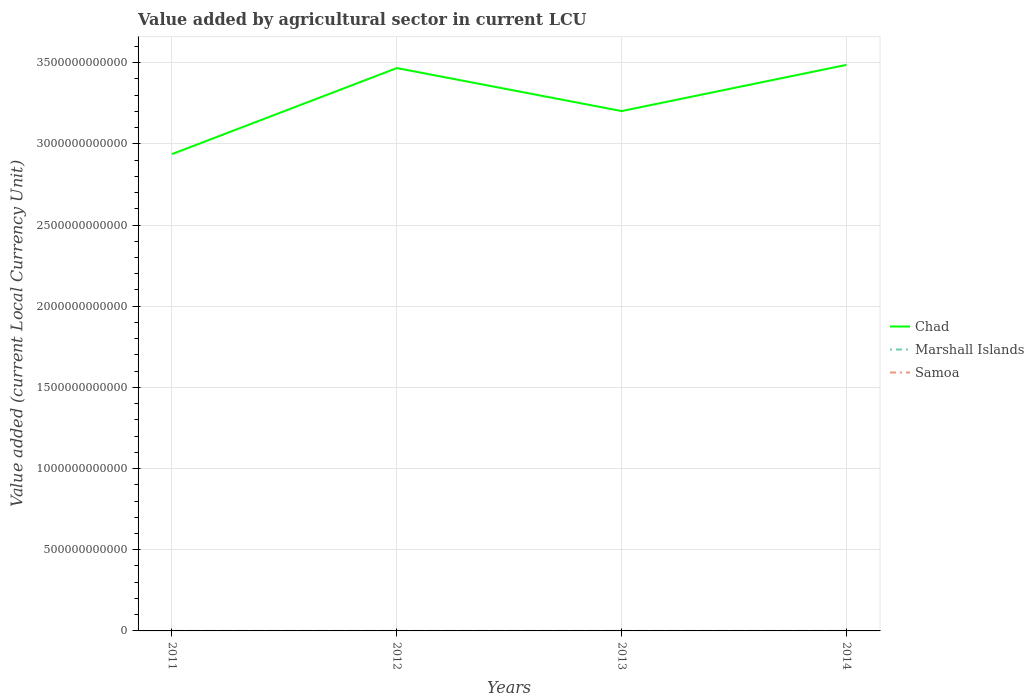Is the number of lines equal to the number of legend labels?
Provide a succinct answer. Yes. Across all years, what is the maximum value added by agricultural sector in Marshall Islands?
Offer a very short reply. 2.65e+07. What is the total value added by agricultural sector in Marshall Islands in the graph?
Offer a very short reply. -1.33e+07. What is the difference between the highest and the second highest value added by agricultural sector in Marshall Islands?
Provide a short and direct response. 1.33e+07. What is the difference between the highest and the lowest value added by agricultural sector in Samoa?
Make the answer very short. 2. Is the value added by agricultural sector in Samoa strictly greater than the value added by agricultural sector in Chad over the years?
Ensure brevity in your answer.  Yes. How many years are there in the graph?
Make the answer very short. 4. What is the difference between two consecutive major ticks on the Y-axis?
Offer a terse response. 5.00e+11. Are the values on the major ticks of Y-axis written in scientific E-notation?
Keep it short and to the point. No. Does the graph contain grids?
Provide a succinct answer. Yes. What is the title of the graph?
Provide a succinct answer. Value added by agricultural sector in current LCU. What is the label or title of the X-axis?
Make the answer very short. Years. What is the label or title of the Y-axis?
Make the answer very short. Value added (current Local Currency Unit). What is the Value added (current Local Currency Unit) of Chad in 2011?
Your response must be concise. 2.94e+12. What is the Value added (current Local Currency Unit) in Marshall Islands in 2011?
Offer a very short reply. 2.65e+07. What is the Value added (current Local Currency Unit) in Samoa in 2011?
Provide a short and direct response. 1.68e+08. What is the Value added (current Local Currency Unit) in Chad in 2012?
Offer a very short reply. 3.47e+12. What is the Value added (current Local Currency Unit) of Marshall Islands in 2012?
Give a very brief answer. 3.96e+07. What is the Value added (current Local Currency Unit) in Samoa in 2012?
Your answer should be very brief. 1.73e+08. What is the Value added (current Local Currency Unit) in Chad in 2013?
Provide a succinct answer. 3.20e+12. What is the Value added (current Local Currency Unit) of Marshall Islands in 2013?
Provide a short and direct response. 3.98e+07. What is the Value added (current Local Currency Unit) in Samoa in 2013?
Ensure brevity in your answer.  1.78e+08. What is the Value added (current Local Currency Unit) in Chad in 2014?
Your answer should be very brief. 3.49e+12. What is the Value added (current Local Currency Unit) in Marshall Islands in 2014?
Offer a very short reply. 3.30e+07. What is the Value added (current Local Currency Unit) in Samoa in 2014?
Give a very brief answer. 1.76e+08. Across all years, what is the maximum Value added (current Local Currency Unit) of Chad?
Make the answer very short. 3.49e+12. Across all years, what is the maximum Value added (current Local Currency Unit) in Marshall Islands?
Offer a very short reply. 3.98e+07. Across all years, what is the maximum Value added (current Local Currency Unit) in Samoa?
Provide a short and direct response. 1.78e+08. Across all years, what is the minimum Value added (current Local Currency Unit) in Chad?
Offer a terse response. 2.94e+12. Across all years, what is the minimum Value added (current Local Currency Unit) of Marshall Islands?
Your response must be concise. 2.65e+07. Across all years, what is the minimum Value added (current Local Currency Unit) in Samoa?
Offer a very short reply. 1.68e+08. What is the total Value added (current Local Currency Unit) in Chad in the graph?
Provide a succinct answer. 1.31e+13. What is the total Value added (current Local Currency Unit) in Marshall Islands in the graph?
Offer a terse response. 1.39e+08. What is the total Value added (current Local Currency Unit) of Samoa in the graph?
Give a very brief answer. 6.95e+08. What is the difference between the Value added (current Local Currency Unit) in Chad in 2011 and that in 2012?
Offer a very short reply. -5.30e+11. What is the difference between the Value added (current Local Currency Unit) in Marshall Islands in 2011 and that in 2012?
Keep it short and to the point. -1.31e+07. What is the difference between the Value added (current Local Currency Unit) of Samoa in 2011 and that in 2012?
Give a very brief answer. -4.91e+06. What is the difference between the Value added (current Local Currency Unit) in Chad in 2011 and that in 2013?
Keep it short and to the point. -2.65e+11. What is the difference between the Value added (current Local Currency Unit) in Marshall Islands in 2011 and that in 2013?
Your answer should be compact. -1.33e+07. What is the difference between the Value added (current Local Currency Unit) of Samoa in 2011 and that in 2013?
Provide a short and direct response. -9.50e+06. What is the difference between the Value added (current Local Currency Unit) in Chad in 2011 and that in 2014?
Offer a very short reply. -5.50e+11. What is the difference between the Value added (current Local Currency Unit) in Marshall Islands in 2011 and that in 2014?
Provide a short and direct response. -6.55e+06. What is the difference between the Value added (current Local Currency Unit) in Samoa in 2011 and that in 2014?
Provide a short and direct response. -7.87e+06. What is the difference between the Value added (current Local Currency Unit) in Chad in 2012 and that in 2013?
Keep it short and to the point. 2.65e+11. What is the difference between the Value added (current Local Currency Unit) of Marshall Islands in 2012 and that in 2013?
Your response must be concise. -2.11e+05. What is the difference between the Value added (current Local Currency Unit) of Samoa in 2012 and that in 2013?
Offer a very short reply. -4.58e+06. What is the difference between the Value added (current Local Currency Unit) of Chad in 2012 and that in 2014?
Keep it short and to the point. -1.97e+1. What is the difference between the Value added (current Local Currency Unit) in Marshall Islands in 2012 and that in 2014?
Provide a succinct answer. 6.57e+06. What is the difference between the Value added (current Local Currency Unit) in Samoa in 2012 and that in 2014?
Ensure brevity in your answer.  -2.95e+06. What is the difference between the Value added (current Local Currency Unit) in Chad in 2013 and that in 2014?
Your answer should be very brief. -2.84e+11. What is the difference between the Value added (current Local Currency Unit) in Marshall Islands in 2013 and that in 2014?
Your answer should be very brief. 6.78e+06. What is the difference between the Value added (current Local Currency Unit) in Samoa in 2013 and that in 2014?
Your answer should be compact. 1.63e+06. What is the difference between the Value added (current Local Currency Unit) of Chad in 2011 and the Value added (current Local Currency Unit) of Marshall Islands in 2012?
Provide a short and direct response. 2.94e+12. What is the difference between the Value added (current Local Currency Unit) of Chad in 2011 and the Value added (current Local Currency Unit) of Samoa in 2012?
Make the answer very short. 2.94e+12. What is the difference between the Value added (current Local Currency Unit) in Marshall Islands in 2011 and the Value added (current Local Currency Unit) in Samoa in 2012?
Provide a short and direct response. -1.47e+08. What is the difference between the Value added (current Local Currency Unit) of Chad in 2011 and the Value added (current Local Currency Unit) of Marshall Islands in 2013?
Ensure brevity in your answer.  2.94e+12. What is the difference between the Value added (current Local Currency Unit) of Chad in 2011 and the Value added (current Local Currency Unit) of Samoa in 2013?
Make the answer very short. 2.94e+12. What is the difference between the Value added (current Local Currency Unit) of Marshall Islands in 2011 and the Value added (current Local Currency Unit) of Samoa in 2013?
Provide a succinct answer. -1.51e+08. What is the difference between the Value added (current Local Currency Unit) of Chad in 2011 and the Value added (current Local Currency Unit) of Marshall Islands in 2014?
Your answer should be compact. 2.94e+12. What is the difference between the Value added (current Local Currency Unit) of Chad in 2011 and the Value added (current Local Currency Unit) of Samoa in 2014?
Ensure brevity in your answer.  2.94e+12. What is the difference between the Value added (current Local Currency Unit) in Marshall Islands in 2011 and the Value added (current Local Currency Unit) in Samoa in 2014?
Provide a succinct answer. -1.50e+08. What is the difference between the Value added (current Local Currency Unit) of Chad in 2012 and the Value added (current Local Currency Unit) of Marshall Islands in 2013?
Make the answer very short. 3.47e+12. What is the difference between the Value added (current Local Currency Unit) in Chad in 2012 and the Value added (current Local Currency Unit) in Samoa in 2013?
Your answer should be very brief. 3.47e+12. What is the difference between the Value added (current Local Currency Unit) in Marshall Islands in 2012 and the Value added (current Local Currency Unit) in Samoa in 2013?
Offer a very short reply. -1.38e+08. What is the difference between the Value added (current Local Currency Unit) of Chad in 2012 and the Value added (current Local Currency Unit) of Marshall Islands in 2014?
Keep it short and to the point. 3.47e+12. What is the difference between the Value added (current Local Currency Unit) in Chad in 2012 and the Value added (current Local Currency Unit) in Samoa in 2014?
Make the answer very short. 3.47e+12. What is the difference between the Value added (current Local Currency Unit) of Marshall Islands in 2012 and the Value added (current Local Currency Unit) of Samoa in 2014?
Your answer should be very brief. -1.36e+08. What is the difference between the Value added (current Local Currency Unit) of Chad in 2013 and the Value added (current Local Currency Unit) of Marshall Islands in 2014?
Keep it short and to the point. 3.20e+12. What is the difference between the Value added (current Local Currency Unit) in Chad in 2013 and the Value added (current Local Currency Unit) in Samoa in 2014?
Your answer should be compact. 3.20e+12. What is the difference between the Value added (current Local Currency Unit) in Marshall Islands in 2013 and the Value added (current Local Currency Unit) in Samoa in 2014?
Ensure brevity in your answer.  -1.36e+08. What is the average Value added (current Local Currency Unit) of Chad per year?
Your answer should be very brief. 3.27e+12. What is the average Value added (current Local Currency Unit) of Marshall Islands per year?
Ensure brevity in your answer.  3.47e+07. What is the average Value added (current Local Currency Unit) of Samoa per year?
Make the answer very short. 1.74e+08. In the year 2011, what is the difference between the Value added (current Local Currency Unit) of Chad and Value added (current Local Currency Unit) of Marshall Islands?
Ensure brevity in your answer.  2.94e+12. In the year 2011, what is the difference between the Value added (current Local Currency Unit) in Chad and Value added (current Local Currency Unit) in Samoa?
Your answer should be compact. 2.94e+12. In the year 2011, what is the difference between the Value added (current Local Currency Unit) of Marshall Islands and Value added (current Local Currency Unit) of Samoa?
Provide a short and direct response. -1.42e+08. In the year 2012, what is the difference between the Value added (current Local Currency Unit) in Chad and Value added (current Local Currency Unit) in Marshall Islands?
Ensure brevity in your answer.  3.47e+12. In the year 2012, what is the difference between the Value added (current Local Currency Unit) in Chad and Value added (current Local Currency Unit) in Samoa?
Your response must be concise. 3.47e+12. In the year 2012, what is the difference between the Value added (current Local Currency Unit) in Marshall Islands and Value added (current Local Currency Unit) in Samoa?
Your answer should be very brief. -1.33e+08. In the year 2013, what is the difference between the Value added (current Local Currency Unit) of Chad and Value added (current Local Currency Unit) of Marshall Islands?
Your answer should be very brief. 3.20e+12. In the year 2013, what is the difference between the Value added (current Local Currency Unit) in Chad and Value added (current Local Currency Unit) in Samoa?
Provide a succinct answer. 3.20e+12. In the year 2013, what is the difference between the Value added (current Local Currency Unit) in Marshall Islands and Value added (current Local Currency Unit) in Samoa?
Ensure brevity in your answer.  -1.38e+08. In the year 2014, what is the difference between the Value added (current Local Currency Unit) of Chad and Value added (current Local Currency Unit) of Marshall Islands?
Ensure brevity in your answer.  3.49e+12. In the year 2014, what is the difference between the Value added (current Local Currency Unit) in Chad and Value added (current Local Currency Unit) in Samoa?
Ensure brevity in your answer.  3.49e+12. In the year 2014, what is the difference between the Value added (current Local Currency Unit) of Marshall Islands and Value added (current Local Currency Unit) of Samoa?
Offer a very short reply. -1.43e+08. What is the ratio of the Value added (current Local Currency Unit) of Chad in 2011 to that in 2012?
Keep it short and to the point. 0.85. What is the ratio of the Value added (current Local Currency Unit) of Marshall Islands in 2011 to that in 2012?
Your answer should be compact. 0.67. What is the ratio of the Value added (current Local Currency Unit) of Samoa in 2011 to that in 2012?
Keep it short and to the point. 0.97. What is the ratio of the Value added (current Local Currency Unit) of Chad in 2011 to that in 2013?
Offer a terse response. 0.92. What is the ratio of the Value added (current Local Currency Unit) of Marshall Islands in 2011 to that in 2013?
Your answer should be very brief. 0.66. What is the ratio of the Value added (current Local Currency Unit) in Samoa in 2011 to that in 2013?
Keep it short and to the point. 0.95. What is the ratio of the Value added (current Local Currency Unit) of Chad in 2011 to that in 2014?
Your answer should be very brief. 0.84. What is the ratio of the Value added (current Local Currency Unit) in Marshall Islands in 2011 to that in 2014?
Provide a succinct answer. 0.8. What is the ratio of the Value added (current Local Currency Unit) in Samoa in 2011 to that in 2014?
Provide a short and direct response. 0.96. What is the ratio of the Value added (current Local Currency Unit) of Chad in 2012 to that in 2013?
Make the answer very short. 1.08. What is the ratio of the Value added (current Local Currency Unit) in Samoa in 2012 to that in 2013?
Your answer should be very brief. 0.97. What is the ratio of the Value added (current Local Currency Unit) of Chad in 2012 to that in 2014?
Ensure brevity in your answer.  0.99. What is the ratio of the Value added (current Local Currency Unit) in Marshall Islands in 2012 to that in 2014?
Your answer should be compact. 1.2. What is the ratio of the Value added (current Local Currency Unit) in Samoa in 2012 to that in 2014?
Offer a very short reply. 0.98. What is the ratio of the Value added (current Local Currency Unit) of Chad in 2013 to that in 2014?
Your answer should be compact. 0.92. What is the ratio of the Value added (current Local Currency Unit) of Marshall Islands in 2013 to that in 2014?
Provide a short and direct response. 1.21. What is the ratio of the Value added (current Local Currency Unit) in Samoa in 2013 to that in 2014?
Offer a very short reply. 1.01. What is the difference between the highest and the second highest Value added (current Local Currency Unit) in Chad?
Your answer should be very brief. 1.97e+1. What is the difference between the highest and the second highest Value added (current Local Currency Unit) in Marshall Islands?
Keep it short and to the point. 2.11e+05. What is the difference between the highest and the second highest Value added (current Local Currency Unit) in Samoa?
Your answer should be compact. 1.63e+06. What is the difference between the highest and the lowest Value added (current Local Currency Unit) of Chad?
Offer a terse response. 5.50e+11. What is the difference between the highest and the lowest Value added (current Local Currency Unit) of Marshall Islands?
Your response must be concise. 1.33e+07. What is the difference between the highest and the lowest Value added (current Local Currency Unit) of Samoa?
Your response must be concise. 9.50e+06. 